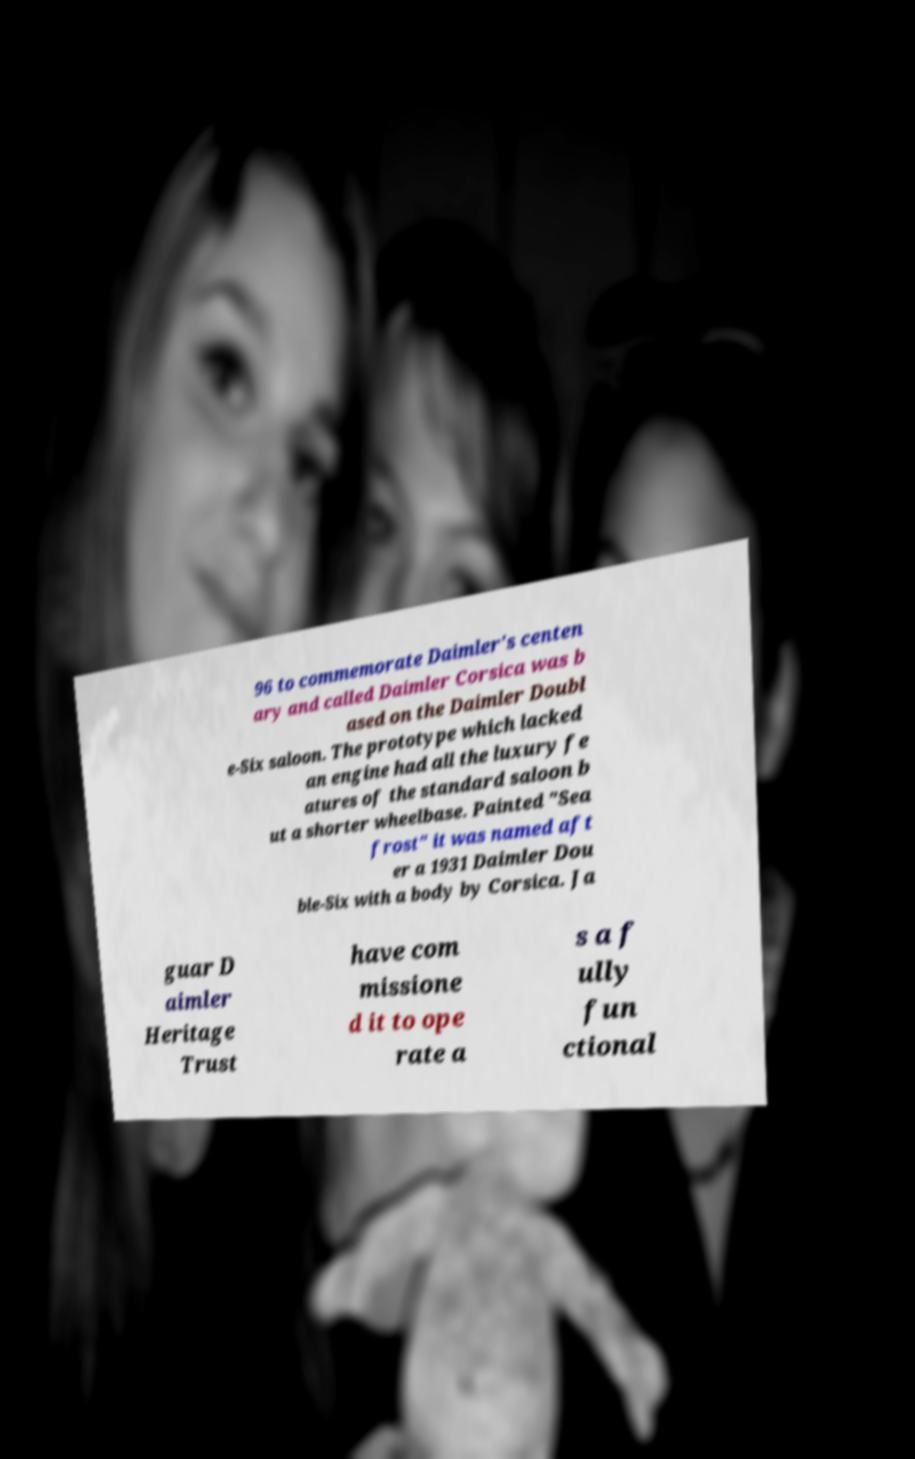Could you extract and type out the text from this image? 96 to commemorate Daimler's centen ary and called Daimler Corsica was b ased on the Daimler Doubl e-Six saloon. The prototype which lacked an engine had all the luxury fe atures of the standard saloon b ut a shorter wheelbase. Painted "Sea frost" it was named aft er a 1931 Daimler Dou ble-Six with a body by Corsica. Ja guar D aimler Heritage Trust have com missione d it to ope rate a s a f ully fun ctional 